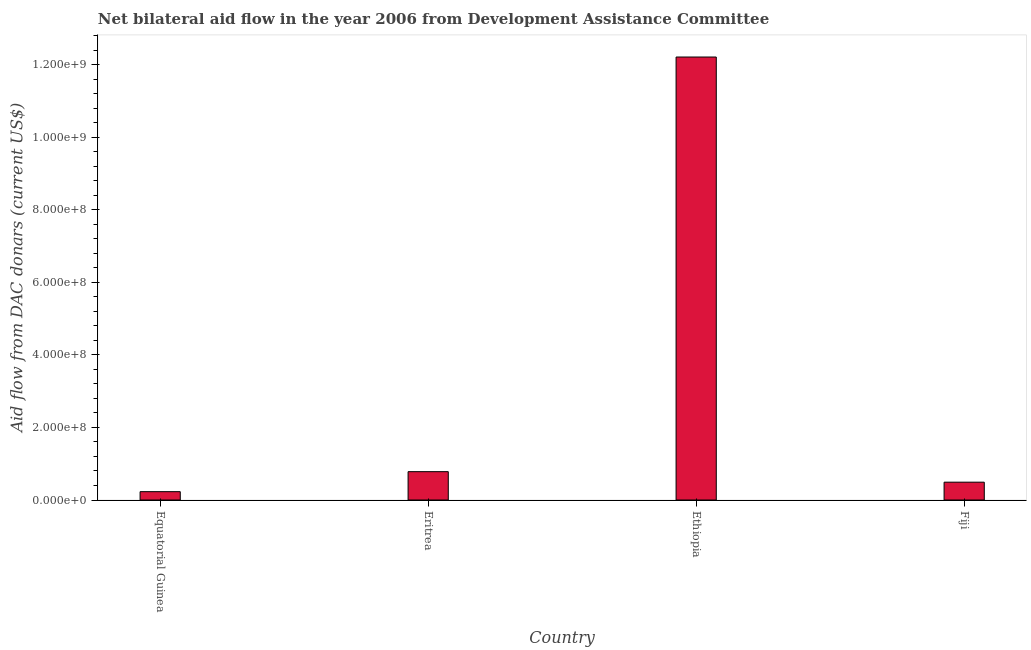Does the graph contain grids?
Keep it short and to the point. No. What is the title of the graph?
Offer a terse response. Net bilateral aid flow in the year 2006 from Development Assistance Committee. What is the label or title of the X-axis?
Offer a very short reply. Country. What is the label or title of the Y-axis?
Ensure brevity in your answer.  Aid flow from DAC donars (current US$). What is the net bilateral aid flows from dac donors in Ethiopia?
Ensure brevity in your answer.  1.22e+09. Across all countries, what is the maximum net bilateral aid flows from dac donors?
Your answer should be very brief. 1.22e+09. Across all countries, what is the minimum net bilateral aid flows from dac donors?
Keep it short and to the point. 2.30e+07. In which country was the net bilateral aid flows from dac donors maximum?
Give a very brief answer. Ethiopia. In which country was the net bilateral aid flows from dac donors minimum?
Provide a short and direct response. Equatorial Guinea. What is the sum of the net bilateral aid flows from dac donors?
Your response must be concise. 1.37e+09. What is the difference between the net bilateral aid flows from dac donors in Equatorial Guinea and Eritrea?
Your response must be concise. -5.52e+07. What is the average net bilateral aid flows from dac donors per country?
Ensure brevity in your answer.  3.43e+08. What is the median net bilateral aid flows from dac donors?
Give a very brief answer. 6.36e+07. In how many countries, is the net bilateral aid flows from dac donors greater than 1200000000 US$?
Provide a succinct answer. 1. What is the ratio of the net bilateral aid flows from dac donors in Equatorial Guinea to that in Ethiopia?
Your response must be concise. 0.02. Is the net bilateral aid flows from dac donors in Eritrea less than that in Ethiopia?
Your response must be concise. Yes. What is the difference between the highest and the second highest net bilateral aid flows from dac donors?
Offer a very short reply. 1.14e+09. What is the difference between the highest and the lowest net bilateral aid flows from dac donors?
Your answer should be very brief. 1.20e+09. How many bars are there?
Your answer should be compact. 4. Are all the bars in the graph horizontal?
Provide a short and direct response. No. Are the values on the major ticks of Y-axis written in scientific E-notation?
Ensure brevity in your answer.  Yes. What is the Aid flow from DAC donars (current US$) of Equatorial Guinea?
Your answer should be very brief. 2.30e+07. What is the Aid flow from DAC donars (current US$) of Eritrea?
Your answer should be very brief. 7.82e+07. What is the Aid flow from DAC donars (current US$) in Ethiopia?
Offer a terse response. 1.22e+09. What is the Aid flow from DAC donars (current US$) of Fiji?
Your answer should be compact. 4.91e+07. What is the difference between the Aid flow from DAC donars (current US$) in Equatorial Guinea and Eritrea?
Make the answer very short. -5.52e+07. What is the difference between the Aid flow from DAC donars (current US$) in Equatorial Guinea and Ethiopia?
Provide a succinct answer. -1.20e+09. What is the difference between the Aid flow from DAC donars (current US$) in Equatorial Guinea and Fiji?
Offer a very short reply. -2.61e+07. What is the difference between the Aid flow from DAC donars (current US$) in Eritrea and Ethiopia?
Your response must be concise. -1.14e+09. What is the difference between the Aid flow from DAC donars (current US$) in Eritrea and Fiji?
Offer a terse response. 2.90e+07. What is the difference between the Aid flow from DAC donars (current US$) in Ethiopia and Fiji?
Offer a very short reply. 1.17e+09. What is the ratio of the Aid flow from DAC donars (current US$) in Equatorial Guinea to that in Eritrea?
Ensure brevity in your answer.  0.29. What is the ratio of the Aid flow from DAC donars (current US$) in Equatorial Guinea to that in Ethiopia?
Ensure brevity in your answer.  0.02. What is the ratio of the Aid flow from DAC donars (current US$) in Equatorial Guinea to that in Fiji?
Keep it short and to the point. 0.47. What is the ratio of the Aid flow from DAC donars (current US$) in Eritrea to that in Ethiopia?
Your answer should be compact. 0.06. What is the ratio of the Aid flow from DAC donars (current US$) in Eritrea to that in Fiji?
Ensure brevity in your answer.  1.59. What is the ratio of the Aid flow from DAC donars (current US$) in Ethiopia to that in Fiji?
Your answer should be compact. 24.86. 